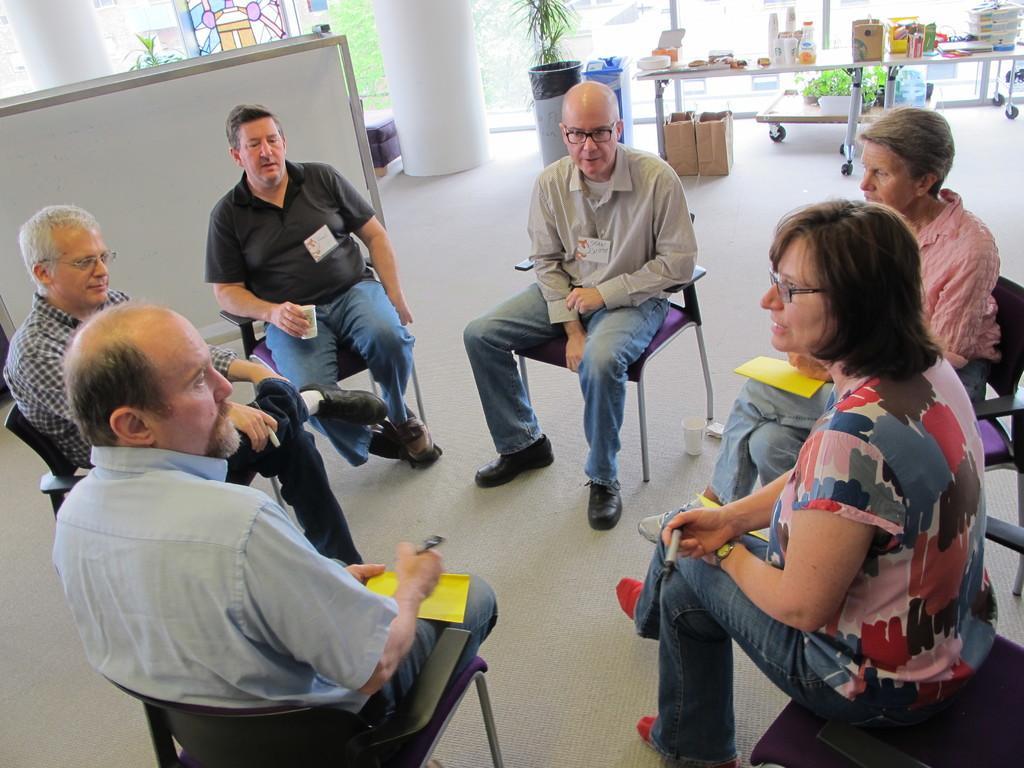In one or two sentences, can you explain what this image depicts? In this image I can see few people are sitting on chairs. In the background I can see a white colour board, few plants, few bags, a table and on it I can see few bottles and few other stuffs. 